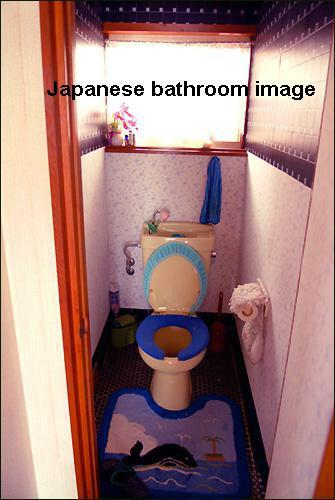Question: who uses the bathroom?
Choices:
A. The captain of the ship.
B. Pirates.
C. Refugees.
D. The people who live there.
Answer with the letter. Answer: D Question: what is on the rug?
Choices:
A. A cat.
B. Books.
C. Dust.
D. A whale in the ocean.
Answer with the letter. Answer: D Question: how many rugs are there?
Choices:
A. Two.
B. One.
C. Three.
D. Four.
Answer with the letter. Answer: B 